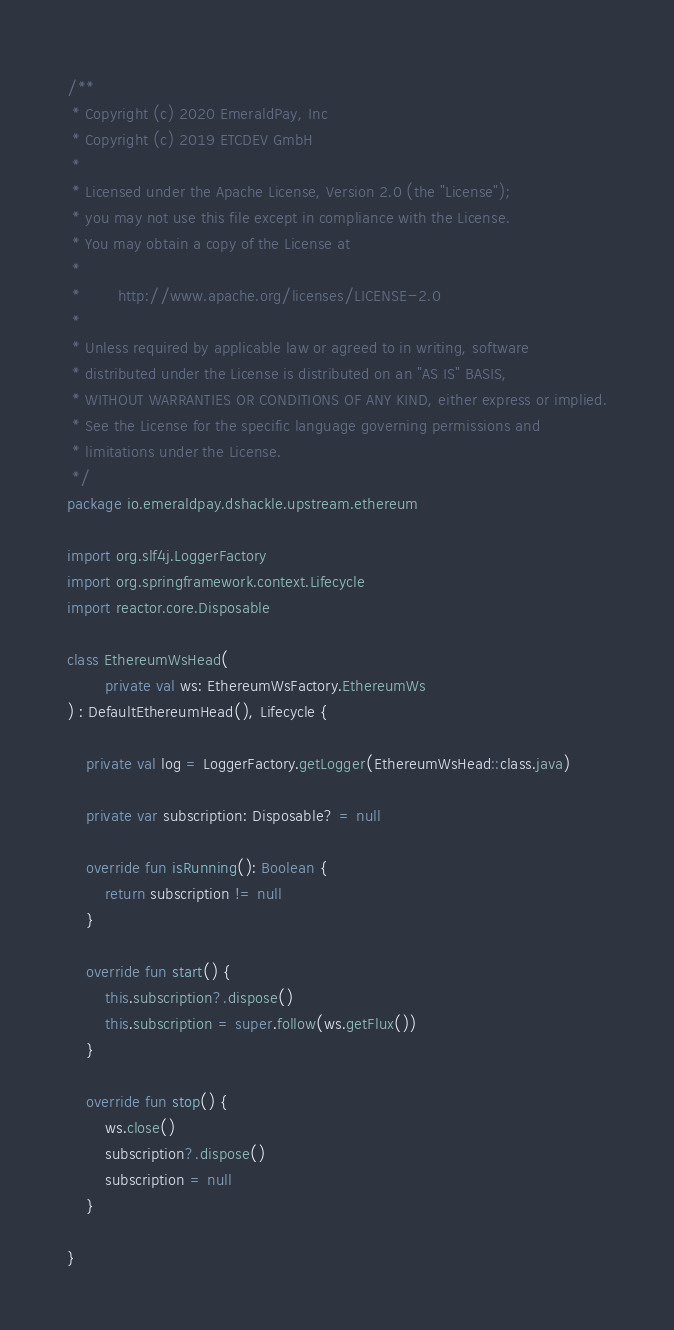Convert code to text. <code><loc_0><loc_0><loc_500><loc_500><_Kotlin_>/**
 * Copyright (c) 2020 EmeraldPay, Inc
 * Copyright (c) 2019 ETCDEV GmbH
 *
 * Licensed under the Apache License, Version 2.0 (the "License");
 * you may not use this file except in compliance with the License.
 * You may obtain a copy of the License at
 *
 *        http://www.apache.org/licenses/LICENSE-2.0
 *
 * Unless required by applicable law or agreed to in writing, software
 * distributed under the License is distributed on an "AS IS" BASIS,
 * WITHOUT WARRANTIES OR CONDITIONS OF ANY KIND, either express or implied.
 * See the License for the specific language governing permissions and
 * limitations under the License.
 */
package io.emeraldpay.dshackle.upstream.ethereum

import org.slf4j.LoggerFactory
import org.springframework.context.Lifecycle
import reactor.core.Disposable

class EthereumWsHead(
        private val ws: EthereumWsFactory.EthereumWs
) : DefaultEthereumHead(), Lifecycle {

    private val log = LoggerFactory.getLogger(EthereumWsHead::class.java)

    private var subscription: Disposable? = null

    override fun isRunning(): Boolean {
        return subscription != null
    }

    override fun start() {
        this.subscription?.dispose()
        this.subscription = super.follow(ws.getFlux())
    }

    override fun stop() {
        ws.close()
        subscription?.dispose()
        subscription = null
    }

}</code> 